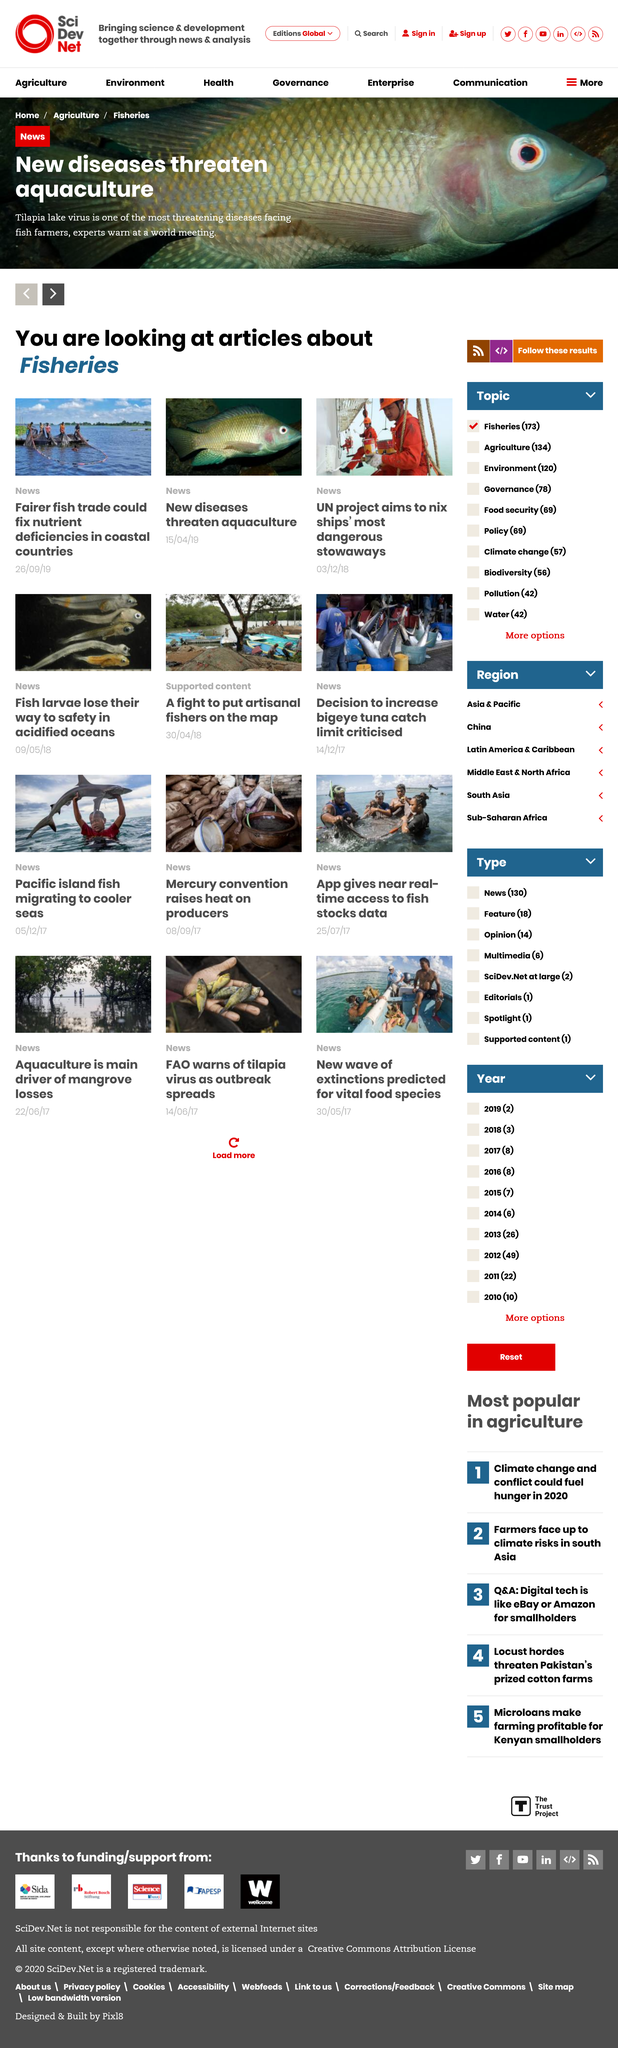Specify some key components in this picture. The article contains four photos. Aquaculture, the farming of aquatic organisms, could be threatened by diseases, as diseases could potentially have a negative impact on the health and growth of the organisms being farmed. We are currently examining articles focused on fisheries in the region. 